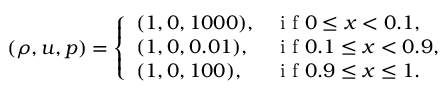Convert formula to latex. <formula><loc_0><loc_0><loc_500><loc_500>( \rho , u , p ) = \left \{ \begin{array} { l l } { ( 1 , 0 , 1 0 0 0 ) , } & { i f 0 \leq x < 0 . 1 , } \\ { ( 1 , 0 , 0 . 0 1 ) , } & { i f 0 . 1 \leq x < 0 . 9 , } \\ { ( 1 , 0 , 1 0 0 ) , } & { i f 0 . 9 \leq x \leq 1 . } \end{array}</formula> 